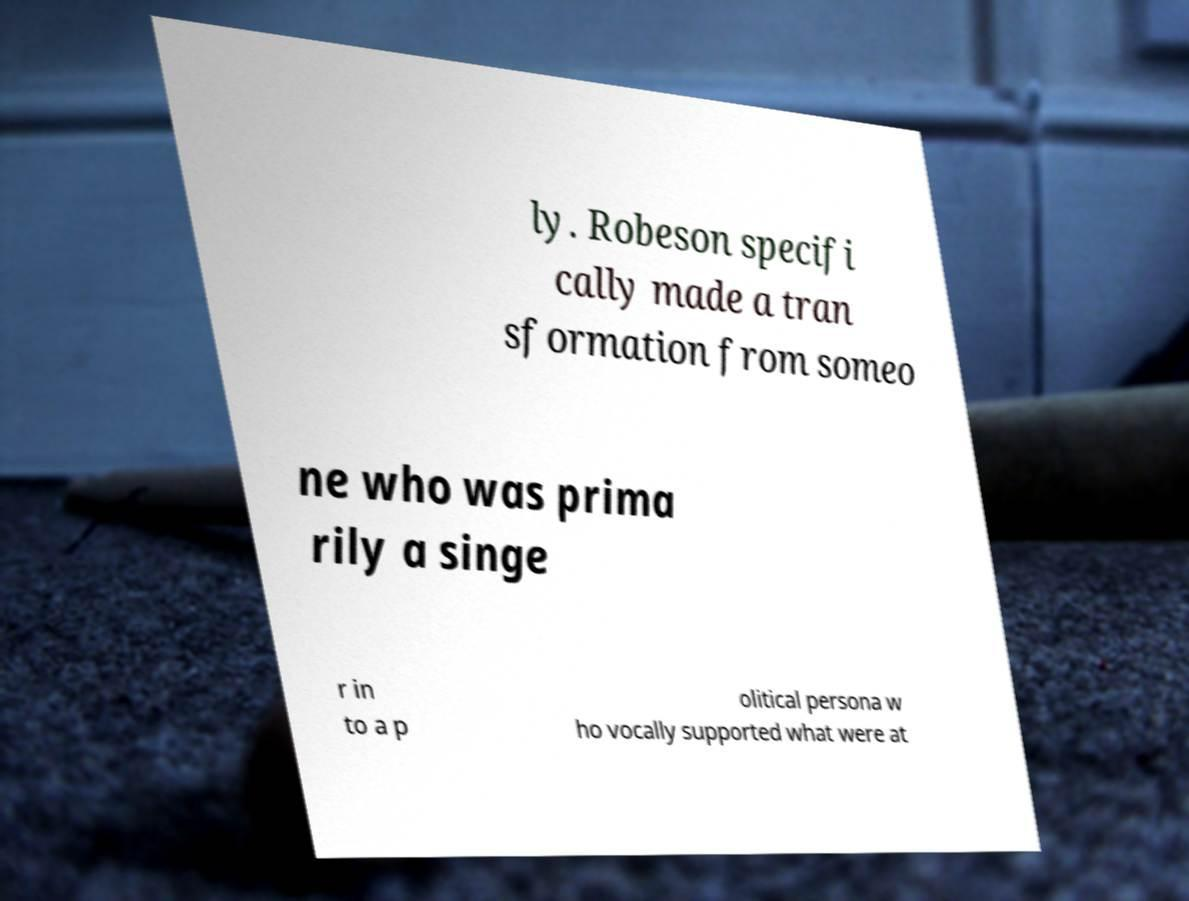Please read and relay the text visible in this image. What does it say? ly. Robeson specifi cally made a tran sformation from someo ne who was prima rily a singe r in to a p olitical persona w ho vocally supported what were at 